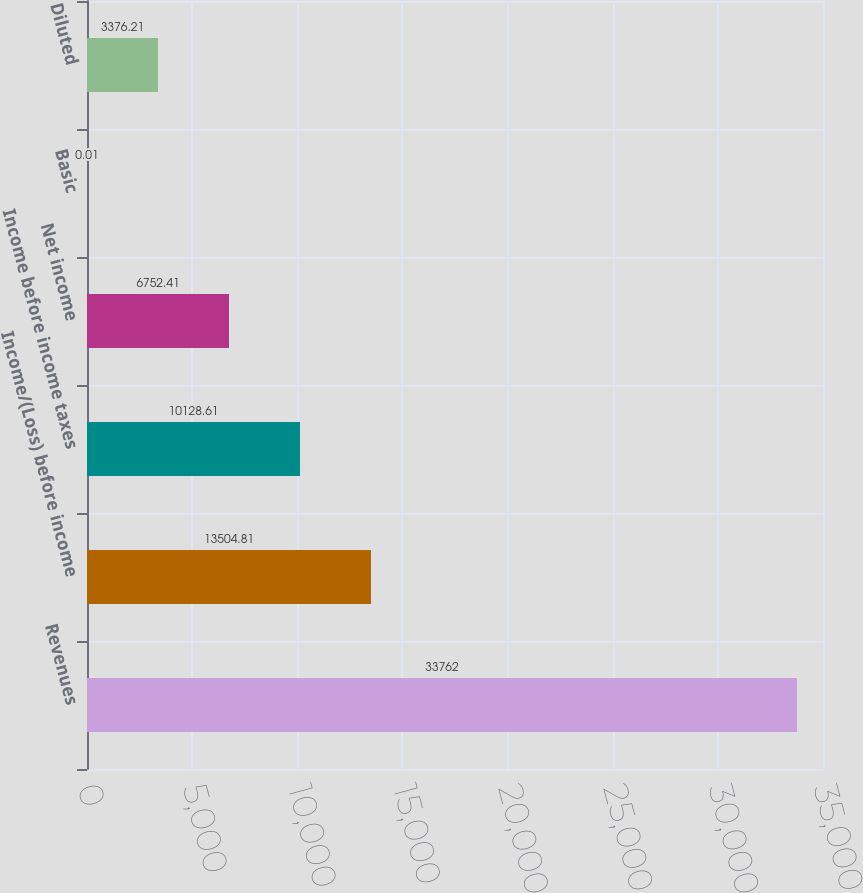Convert chart. <chart><loc_0><loc_0><loc_500><loc_500><bar_chart><fcel>Revenues<fcel>Income/(Loss) before income<fcel>Income before income taxes<fcel>Net income<fcel>Basic<fcel>Diluted<nl><fcel>33762<fcel>13504.8<fcel>10128.6<fcel>6752.41<fcel>0.01<fcel>3376.21<nl></chart> 